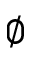Convert formula to latex. <formula><loc_0><loc_0><loc_500><loc_500>\emptyset</formula> 